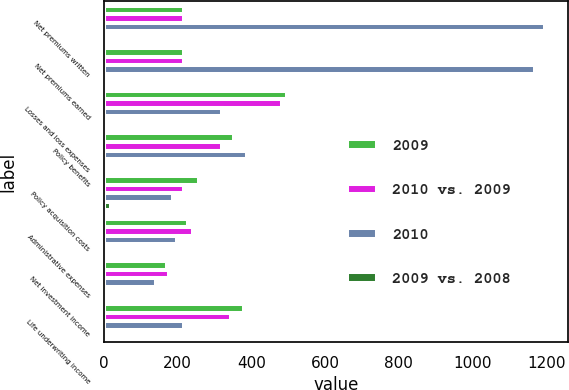Convert chart. <chart><loc_0><loc_0><loc_500><loc_500><stacked_bar_chart><ecel><fcel>Net premiums written<fcel>Net premiums earned<fcel>Losses and loss expenses<fcel>Policy benefits<fcel>Policy acquisition costs<fcel>Administrative expenses<fcel>Net investment income<fcel>Life underwriting income<nl><fcel>2009<fcel>217<fcel>217<fcel>496<fcel>353<fcel>257<fcel>228<fcel>172<fcel>380<nl><fcel>2010 vs. 2009<fcel>217<fcel>217<fcel>482<fcel>321<fcel>216<fcel>243<fcel>176<fcel>344<nl><fcel>2010<fcel>1198<fcel>1170<fcel>320<fcel>387<fcel>188<fcel>199<fcel>142<fcel>218<nl><fcel>2009 vs. 2008<fcel>5<fcel>8<fcel>3<fcel>10<fcel>19<fcel>6<fcel>2<fcel>10<nl></chart> 